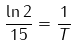<formula> <loc_0><loc_0><loc_500><loc_500>\frac { \ln 2 } { 1 5 } = \frac { 1 } { T }</formula> 